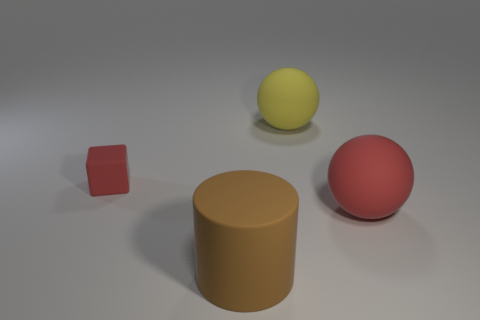Subtract all yellow balls. How many balls are left? 1 Add 1 matte balls. How many objects exist? 5 Subtract all blocks. How many objects are left? 3 Subtract 1 red cubes. How many objects are left? 3 Subtract all brown balls. Subtract all yellow cubes. How many balls are left? 2 Subtract all small purple matte balls. Subtract all red blocks. How many objects are left? 3 Add 2 large red matte spheres. How many large red matte spheres are left? 3 Add 4 cylinders. How many cylinders exist? 5 